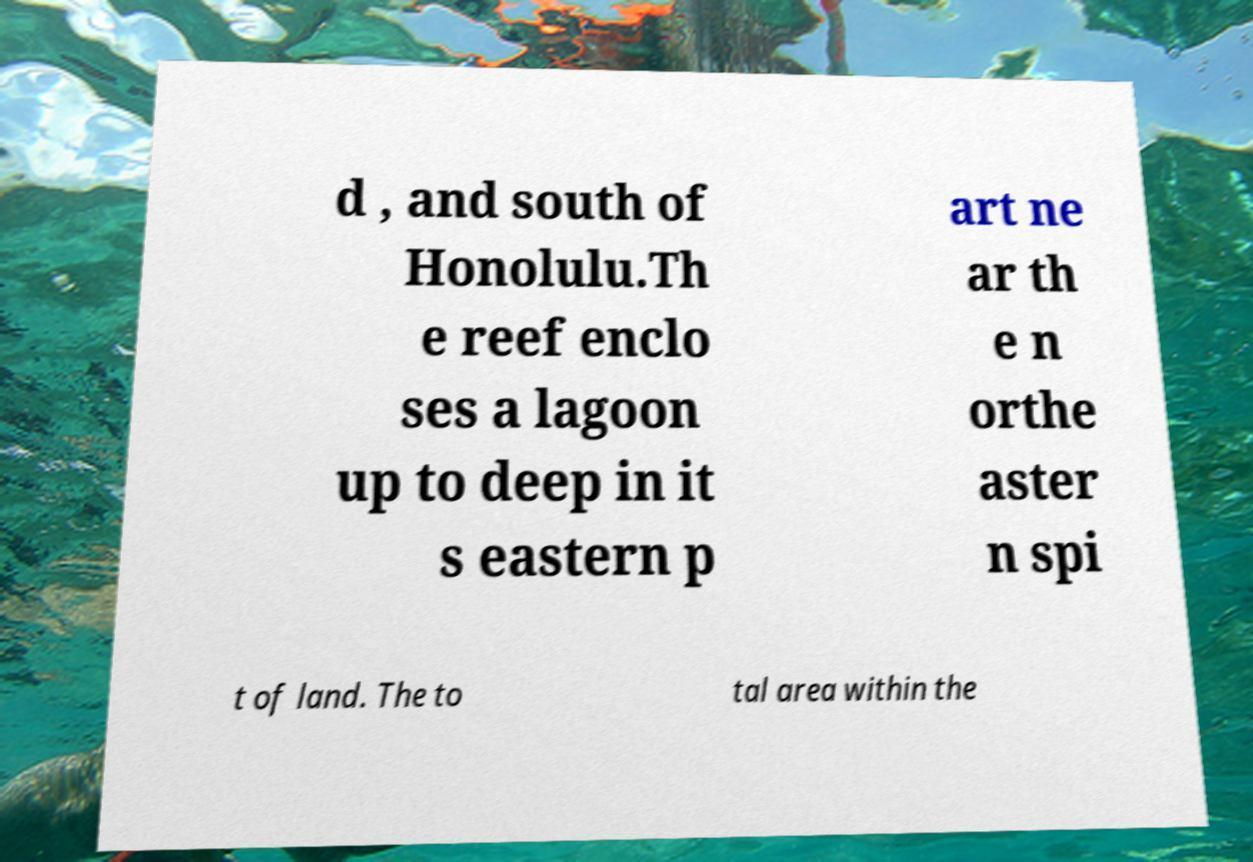Can you read and provide the text displayed in the image?This photo seems to have some interesting text. Can you extract and type it out for me? d , and south of Honolulu.Th e reef enclo ses a lagoon up to deep in it s eastern p art ne ar th e n orthe aster n spi t of land. The to tal area within the 